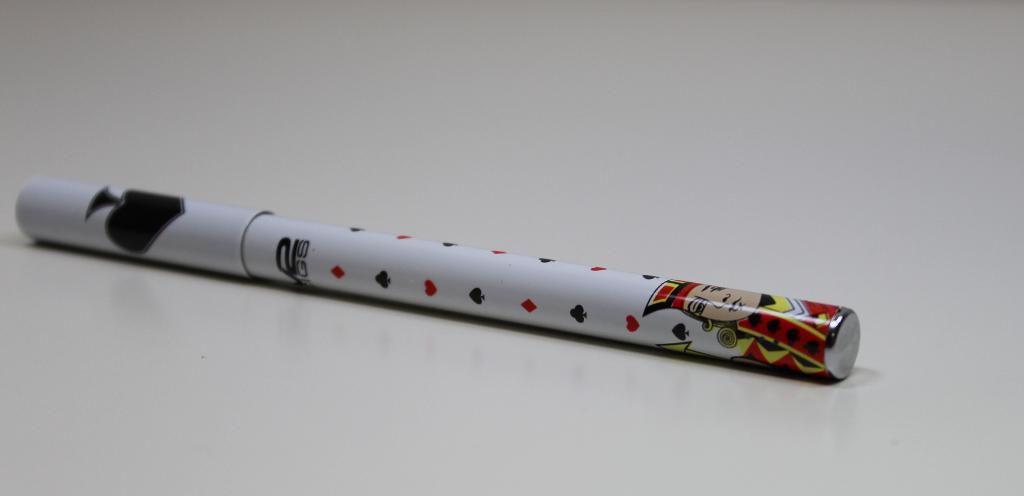What object is present in the image? There is a marker in the image. What is the marker placed on? The marker is on a white color platform. What disease is the marker trying to cure in the image? There is no indication of a disease or any medical context in the image; it simply features a marker on a white platform. 